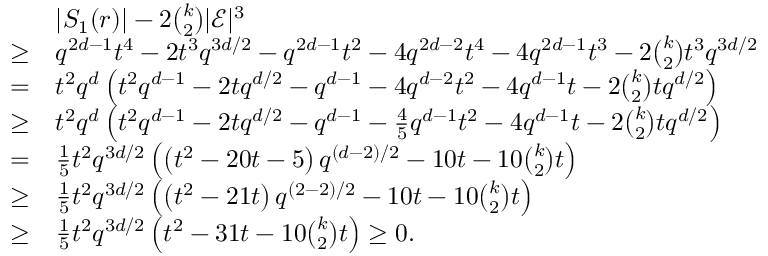<formula> <loc_0><loc_0><loc_500><loc_500>\begin{array} { r l } & { | S _ { 1 } ( r ) | - 2 { \binom { k } { 2 } } | \mathcal { E } | ^ { 3 } } \\ { \geq } & { q ^ { 2 d - 1 } t ^ { 4 } - 2 t ^ { 3 } q ^ { 3 d / 2 } - q ^ { 2 d - 1 } t ^ { 2 } - 4 q ^ { 2 d - 2 } t ^ { 4 } - 4 q ^ { 2 d - 1 } t ^ { 3 } - 2 { \binom { k } { 2 } } t ^ { 3 } q ^ { 3 d / 2 } } \\ { = } & { t ^ { 2 } q ^ { d } \left ( t ^ { 2 } q ^ { d - 1 } - 2 t q ^ { d / 2 } - q ^ { d - 1 } - 4 q ^ { d - 2 } t ^ { 2 } - 4 q ^ { d - 1 } t - 2 { \binom { k } { 2 } } t q ^ { d / 2 } \right ) } \\ { \geq } & { t ^ { 2 } q ^ { d } \left ( t ^ { 2 } q ^ { d - 1 } - 2 t q ^ { d / 2 } - q ^ { d - 1 } - \frac { 4 } { 5 } q ^ { d - 1 } t ^ { 2 } - 4 q ^ { d - 1 } t - 2 { \binom { k } { 2 } } t q ^ { d / 2 } \right ) } \\ { = } & { \frac { 1 } { 5 } t ^ { 2 } q ^ { 3 d / 2 } \left ( \left ( t ^ { 2 } - 2 0 t - 5 \right ) q ^ { ( d - 2 ) / 2 } - 1 0 t - 1 0 { \binom { k } { 2 } } t \right ) } \\ { \geq } & { \frac { 1 } { 5 } t ^ { 2 } q ^ { 3 d / 2 } \left ( \left ( t ^ { 2 } - 2 1 t \right ) q ^ { ( 2 - 2 ) / 2 } - 1 0 t - 1 0 { \binom { k } { 2 } } t \right ) } \\ { \geq } & { \frac { 1 } { 5 } t ^ { 2 } q ^ { 3 d / 2 } \left ( t ^ { 2 } - 3 1 t - 1 0 { \binom { k } { 2 } } t \right ) \geq 0 . } \end{array}</formula> 